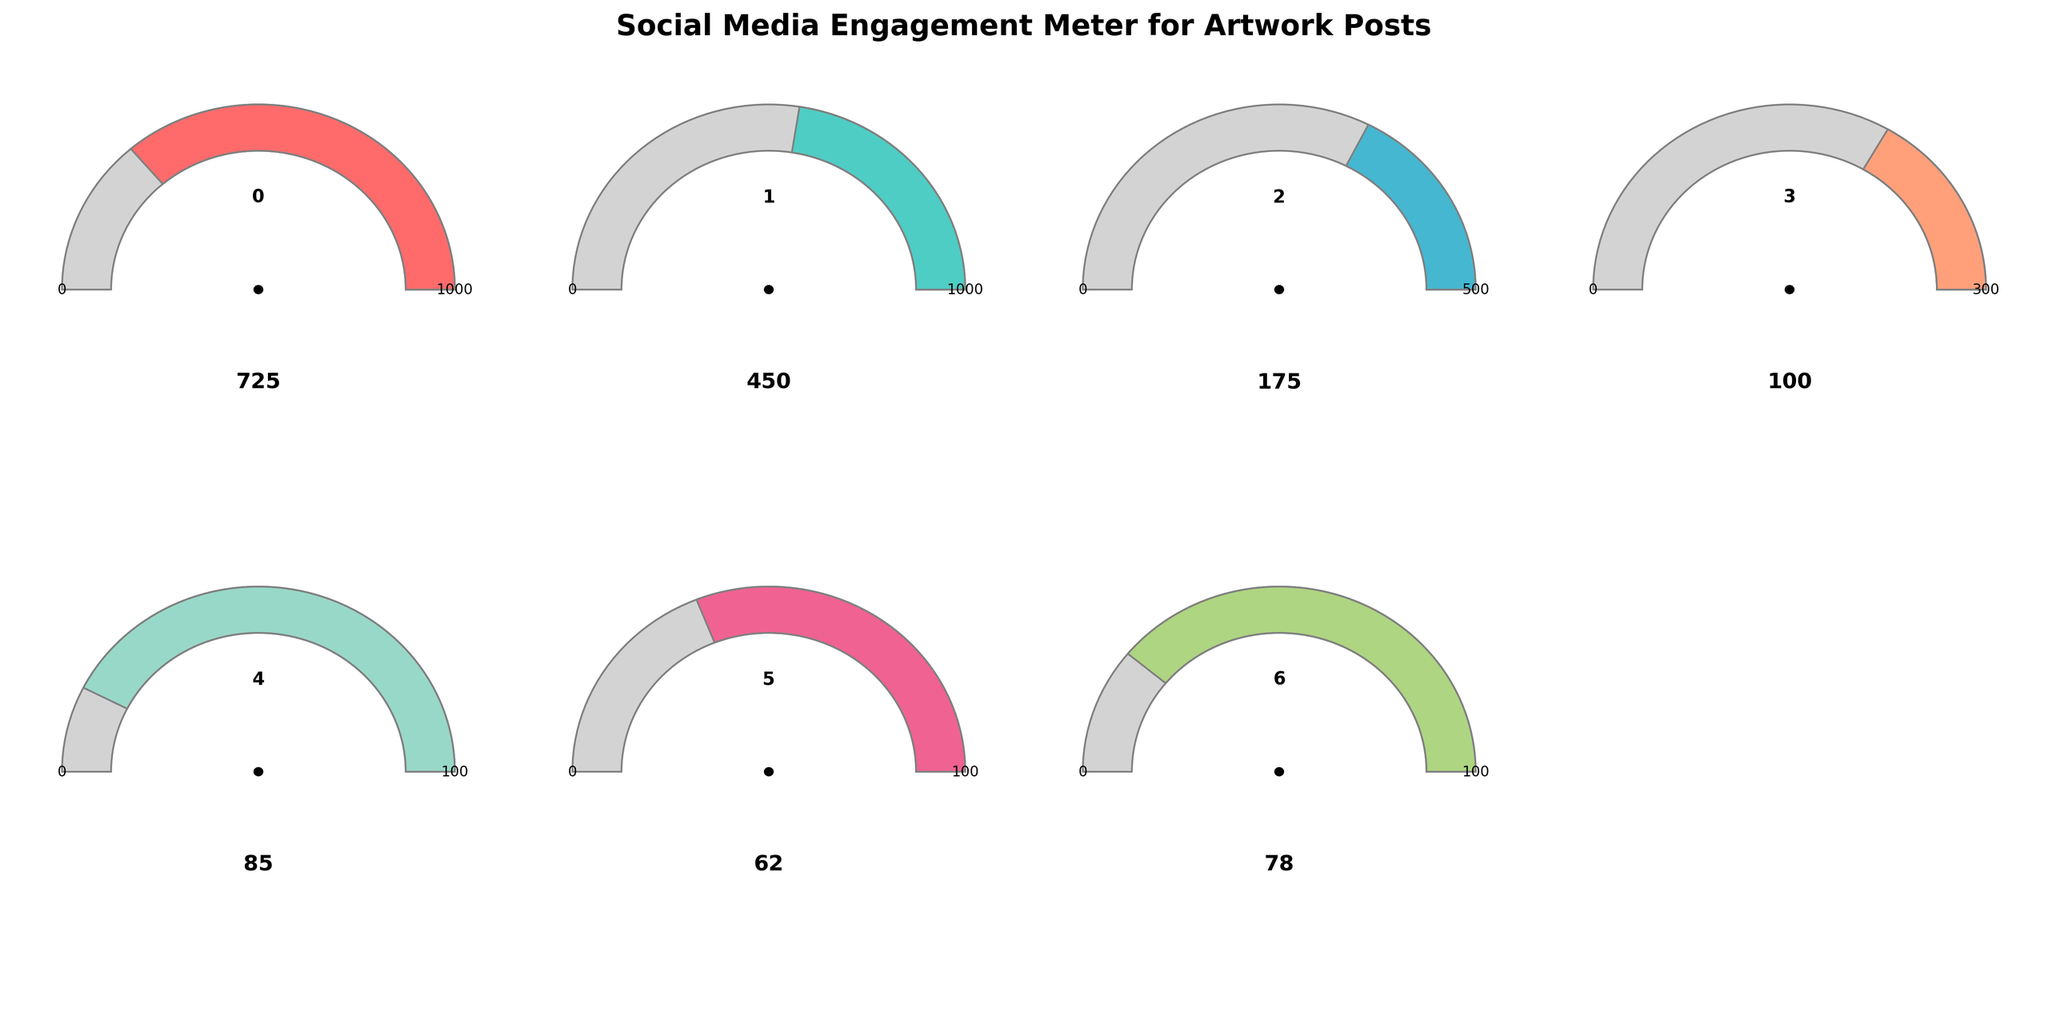What is the total engagement value for artwork posts? The total engagement value is represented on the gauge for "Total Engagement," which shows the value as 725.
Answer: 725 What is the maximum possible value for likes on artwork posts? The gauge for "Likes" shows the maximum value as 1000, indicated at the right end of the gauge.
Answer: 1000 How many comments are received on artwork posts compared to likes? We need to look at the values for both "Comments" and "Likes." The gauge for "Comments" shows 100, while the gauge for "Likes" shows 450.
Answer: 100 for comments and 450 for likes What is the average value of likes, shares, and comments on the artwork posts? The average can be calculated by adding the values of likes (450), shares (175), and comments (100), and then dividing by 3. So, (450 + 175 + 100) / 3 = 725 / 3 = 241.67
Answer: 241.67 Which artwork category has the lowest engagement value? We need to compare the values of "Stroh-Inspired Posts," "Portrait Sketches," and "Abstract Paintings." The values are 85, 62, and 78, respectively. "Portrait Sketches" has the lowest value.
Answer: Portrait Sketches What is the difference between the high threshold and the actual value for Stroh-Inspired Posts? The high threshold for Stroh-Inspired Posts is 80, and the actual value is 85. The difference is 85 - 80.
Answer: 5 Which category is closer to reaching its high threshold: Abstract Paintings or Shares? The high threshold for Abstract Paintings is 90, with an actual value of 78. This gives a difference of 90 - 78 = 12. For Shares, the high threshold is 200, with an actual value of 175, giving a difference of 200 - 175 = 25. Abstract Paintings are closer.
Answer: Abstract Paintings How many more likes are needed to reach the high threshold on engagement for likes? The high threshold for likes is 600, and the current value is 450. The number of additional likes required is 600 - 450.
Answer: 150 What is the visual representation color for the "Shares" gauge? The gauge for "Shares" is colored in light cyan.
Answer: light cyan Which data point surpasses its high threshold value? We need to compare the actual values to their high thresholds. Stroh-Inspired Posts have an actual value of 85 and a high threshold of 80, indicating it surpasses its high threshold.
Answer: Stroh-Inspired Posts 